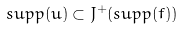<formula> <loc_0><loc_0><loc_500><loc_500>s u p p ( u ) \subset J ^ { + } ( s u p p ( f ) )</formula> 